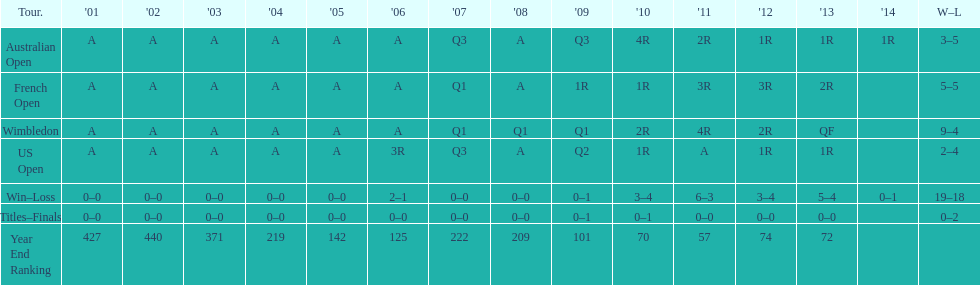What was the total number of matches played from 2001 to 2014? 37. 